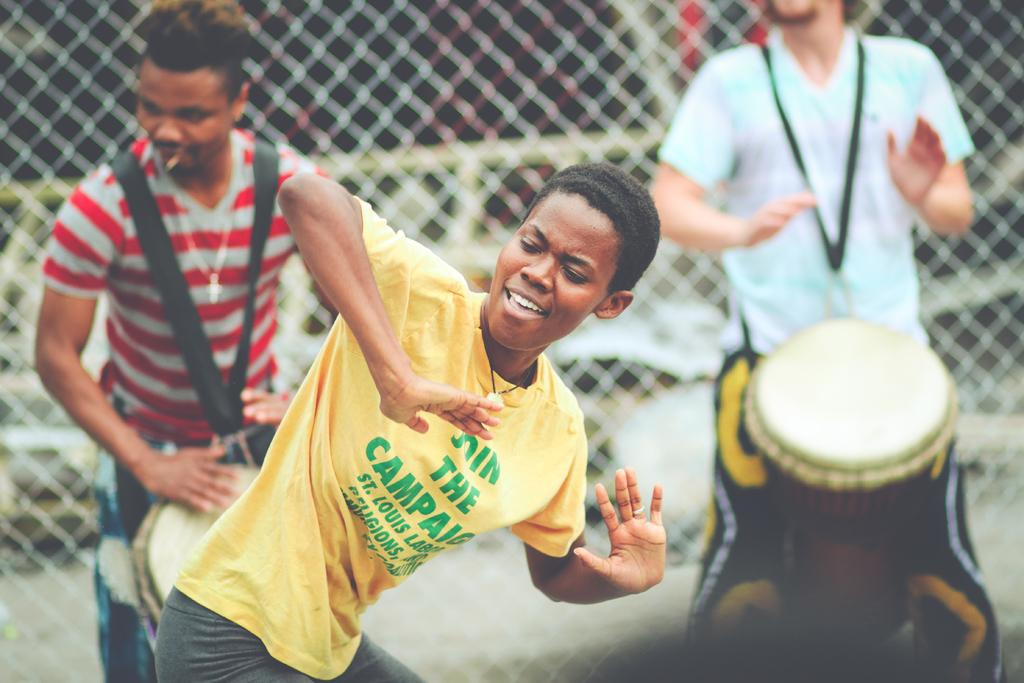What is the man in the image doing? The man is dancing in the image. What is the man wearing? The man is wearing a t-shirt. How many people are in the image? There are two people in the image. What are the two people doing? The two people are playing a drum with their hands. What can be seen in the background of the image? There is a net visible in the background of the image. What type of rose is the man holding in the image? There is no rose present in the image; the man is dancing and wearing a t-shirt. 